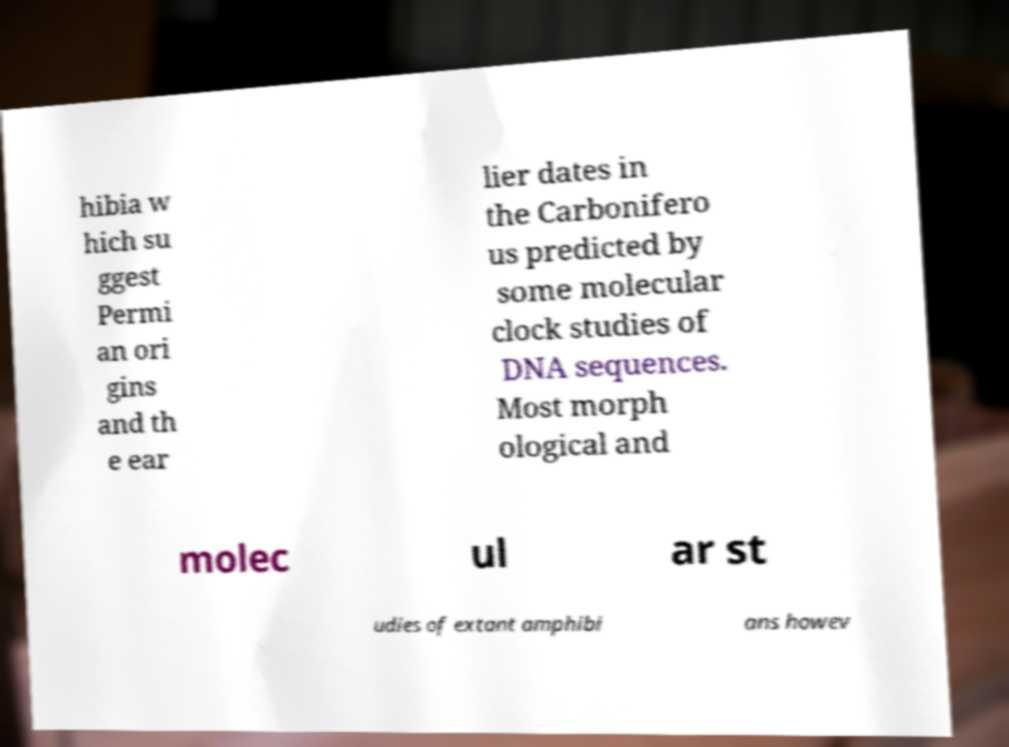Could you extract and type out the text from this image? hibia w hich su ggest Permi an ori gins and th e ear lier dates in the Carbonifero us predicted by some molecular clock studies of DNA sequences. Most morph ological and molec ul ar st udies of extant amphibi ans howev 